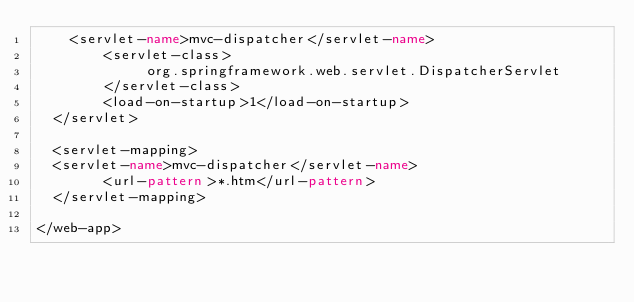<code> <loc_0><loc_0><loc_500><loc_500><_XML_>  	<servlet-name>mvc-dispatcher</servlet-name>
        <servlet-class>
             org.springframework.web.servlet.DispatcherServlet
        </servlet-class>
        <load-on-startup>1</load-on-startup>
  </servlet>

  <servlet-mapping>
 	<servlet-name>mvc-dispatcher</servlet-name>
        <url-pattern>*.htm</url-pattern>
  </servlet-mapping>

</web-app></code> 